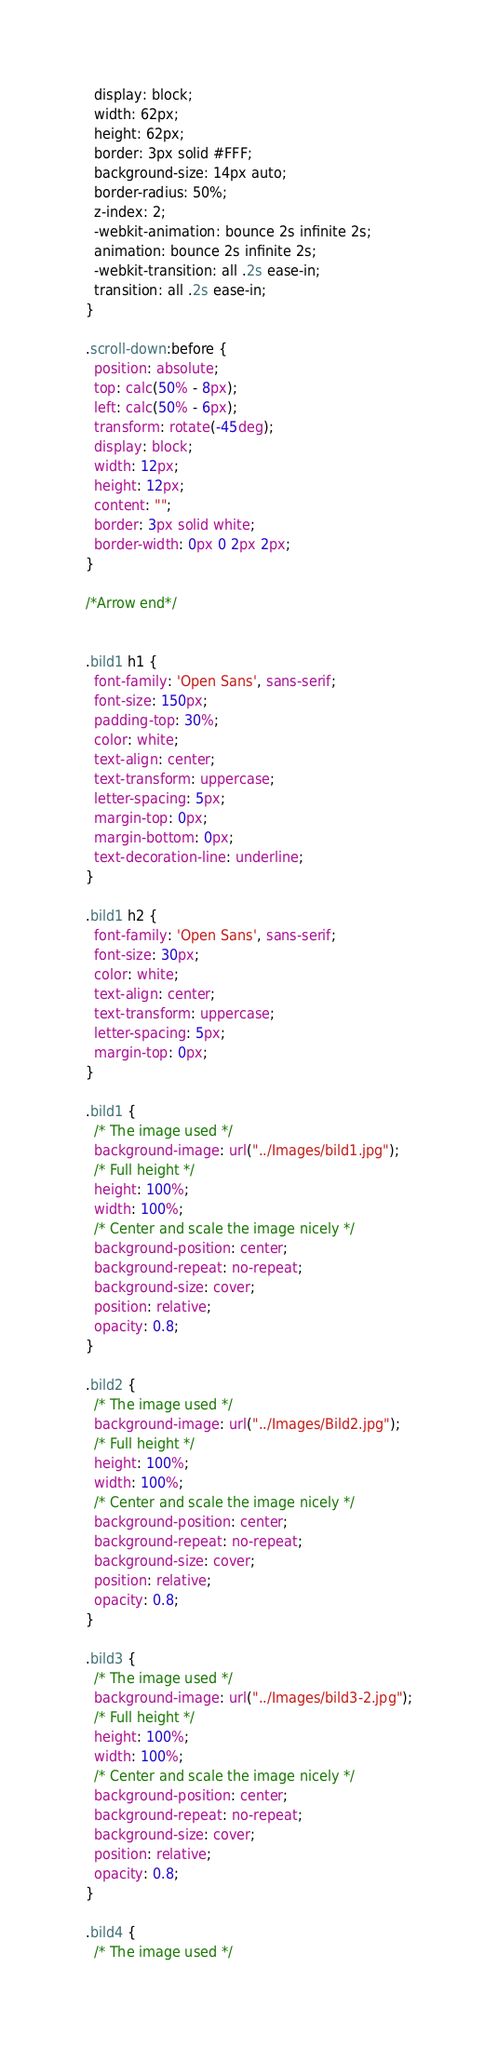Convert code to text. <code><loc_0><loc_0><loc_500><loc_500><_CSS_>  display: block;
  width: 62px;
  height: 62px;
  border: 3px solid #FFF;
  background-size: 14px auto;
  border-radius: 50%;
  z-index: 2;
  -webkit-animation: bounce 2s infinite 2s;
  animation: bounce 2s infinite 2s;
  -webkit-transition: all .2s ease-in;
  transition: all .2s ease-in;
}

.scroll-down:before {
  position: absolute;
  top: calc(50% - 8px);
  left: calc(50% - 6px);
  transform: rotate(-45deg);
  display: block;
  width: 12px;
  height: 12px;
  content: "";
  border: 3px solid white;
  border-width: 0px 0 2px 2px;
}

/*Arrow end*/


.bild1 h1 {
  font-family: 'Open Sans', sans-serif;
  font-size: 150px;
  padding-top: 30%;
  color: white;
  text-align: center;
  text-transform: uppercase;
  letter-spacing: 5px;
  margin-top: 0px;
  margin-bottom: 0px;
  text-decoration-line: underline;
}

.bild1 h2 {
  font-family: 'Open Sans', sans-serif;
  font-size: 30px;
  color: white;
  text-align: center;
  text-transform: uppercase;
  letter-spacing: 5px;
  margin-top: 0px;
}

.bild1 {
  /* The image used */
  background-image: url("../Images/bild1.jpg");
  /* Full height */
  height: 100%;
  width: 100%;
  /* Center and scale the image nicely */
  background-position: center;
  background-repeat: no-repeat;
  background-size: cover;
  position: relative;
  opacity: 0.8;
}

.bild2 {
  /* The image used */
  background-image: url("../Images/Bild2.jpg");
  /* Full height */
  height: 100%;
  width: 100%;
  /* Center and scale the image nicely */
  background-position: center;
  background-repeat: no-repeat;
  background-size: cover;
  position: relative;
  opacity: 0.8;
}

.bild3 {
  /* The image used */
  background-image: url("../Images/bild3-2.jpg");
  /* Full height */
  height: 100%;
  width: 100%;
  /* Center and scale the image nicely */
  background-position: center;
  background-repeat: no-repeat;
  background-size: cover;
  position: relative;
  opacity: 0.8;
}

.bild4 {
  /* The image used */</code> 